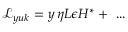Convert formula to latex. <formula><loc_0><loc_0><loc_500><loc_500>{ \mathcal { L } } _ { y u k } = y \, \eta L \epsilon H ^ { * } + \dots</formula> 